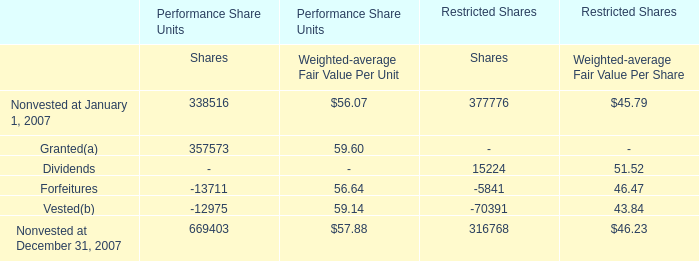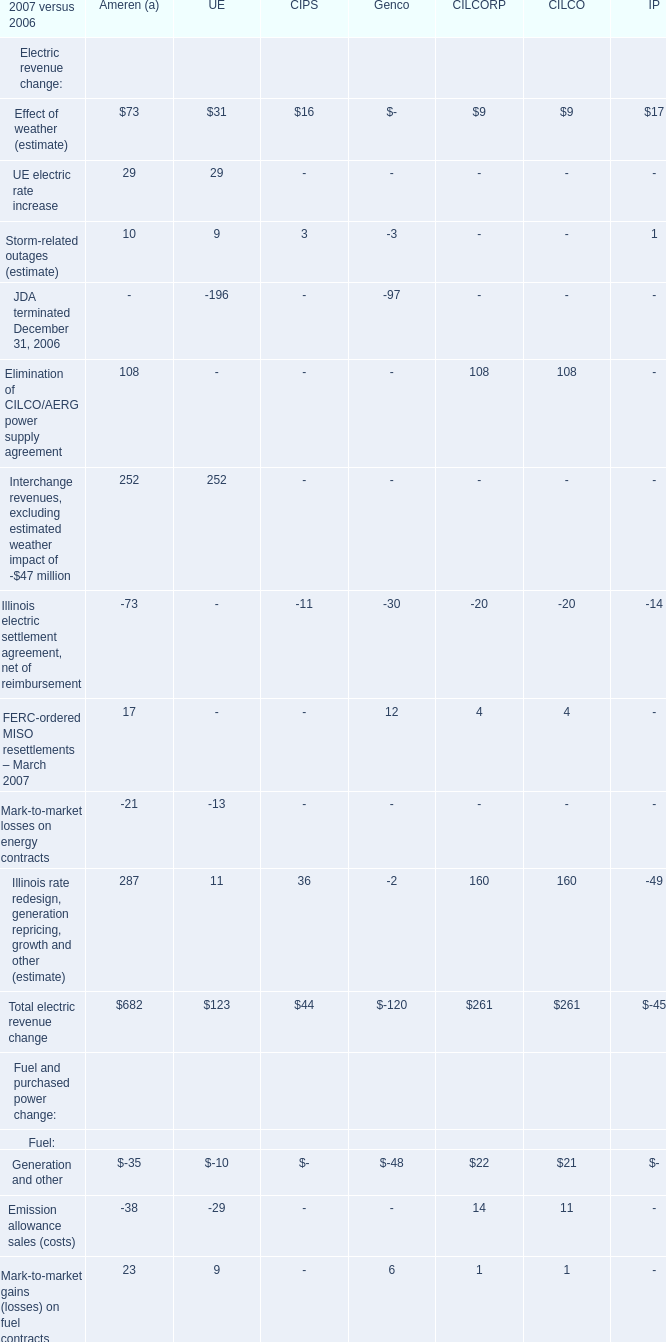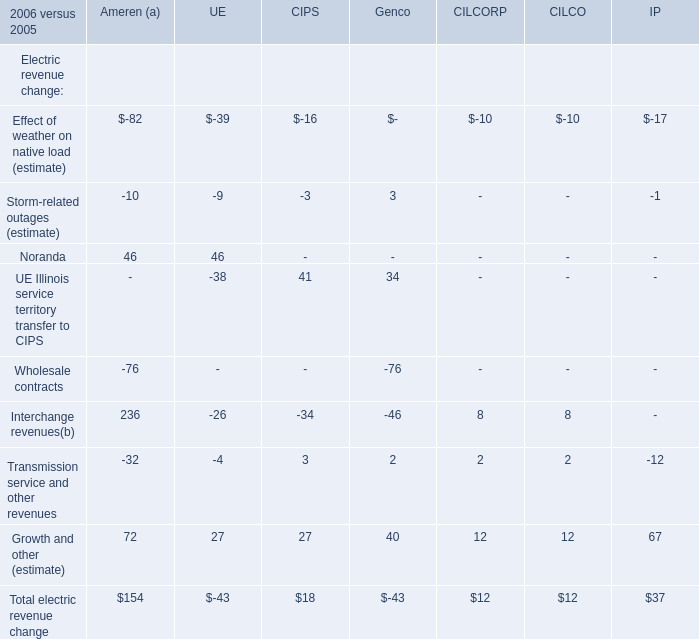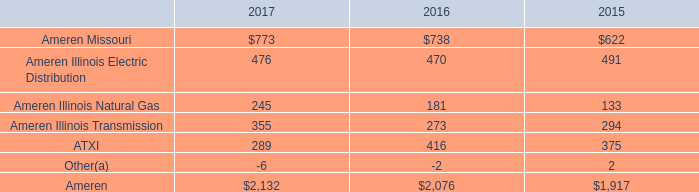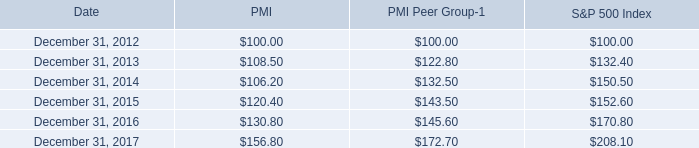what is the growth rate in pmi's share price from 2012 to 2013? 
Computations: ((108.50 - 100) / 100)
Answer: 0.085. 